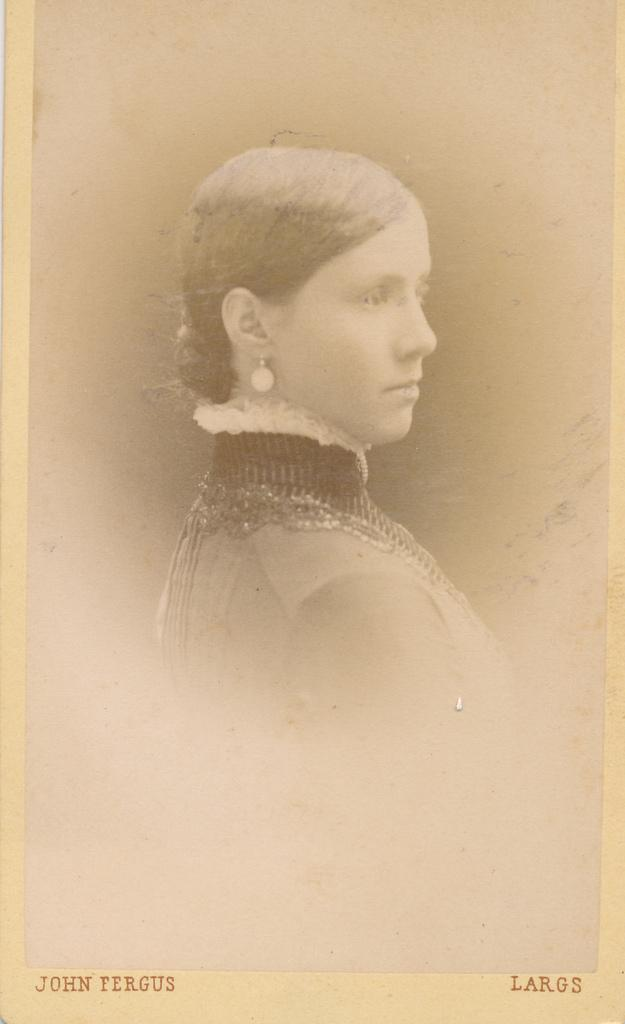What is the main subject of the image? The main subject of the image is a photograph of a person. Is there any text present in the image? Yes, there is some text at the bottom of the image. What type of twig is the person holding in the photograph? There is no twig present in the photograph; it only features a person. How many cars can be seen in the image? There are no cars present in the image. 